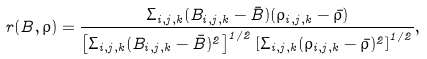<formula> <loc_0><loc_0><loc_500><loc_500>r ( B , \rho ) = \frac { { \Sigma } _ { i , j , k } ( B _ { i , j , k } - \bar { B } ) ( \rho _ { i , j , k } - \bar { \rho } ) } { \left [ \Sigma _ { i , j , k } ( B _ { i , j , k } - \bar { B } ) ^ { 2 } \right ] ^ { 1 / 2 } \left [ \Sigma _ { i , j , k } ( \rho _ { i , j , k } - \bar { \rho } ) ^ { 2 } \right ] ^ { 1 / 2 } } ,</formula> 